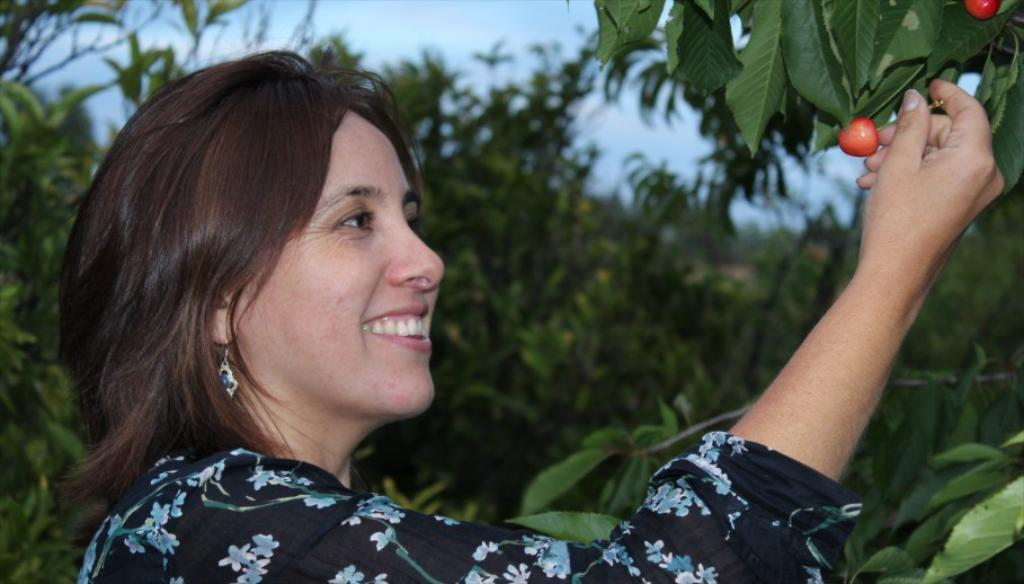Who is present in the image? There is a woman in the image. What is the woman doing in the image? The woman is smiling in the image. What can be seen in the background of the image? There are trees in the background of the image. What is the woman holding in the image? The woman is holding fruits in the image. Where are the fruits located before the woman holds them? The fruits are on a tree before the woman holds them. What type of plot is the woman standing on in the image? There is no plot visible in the image; it appears to be a natural setting with trees in the background. 